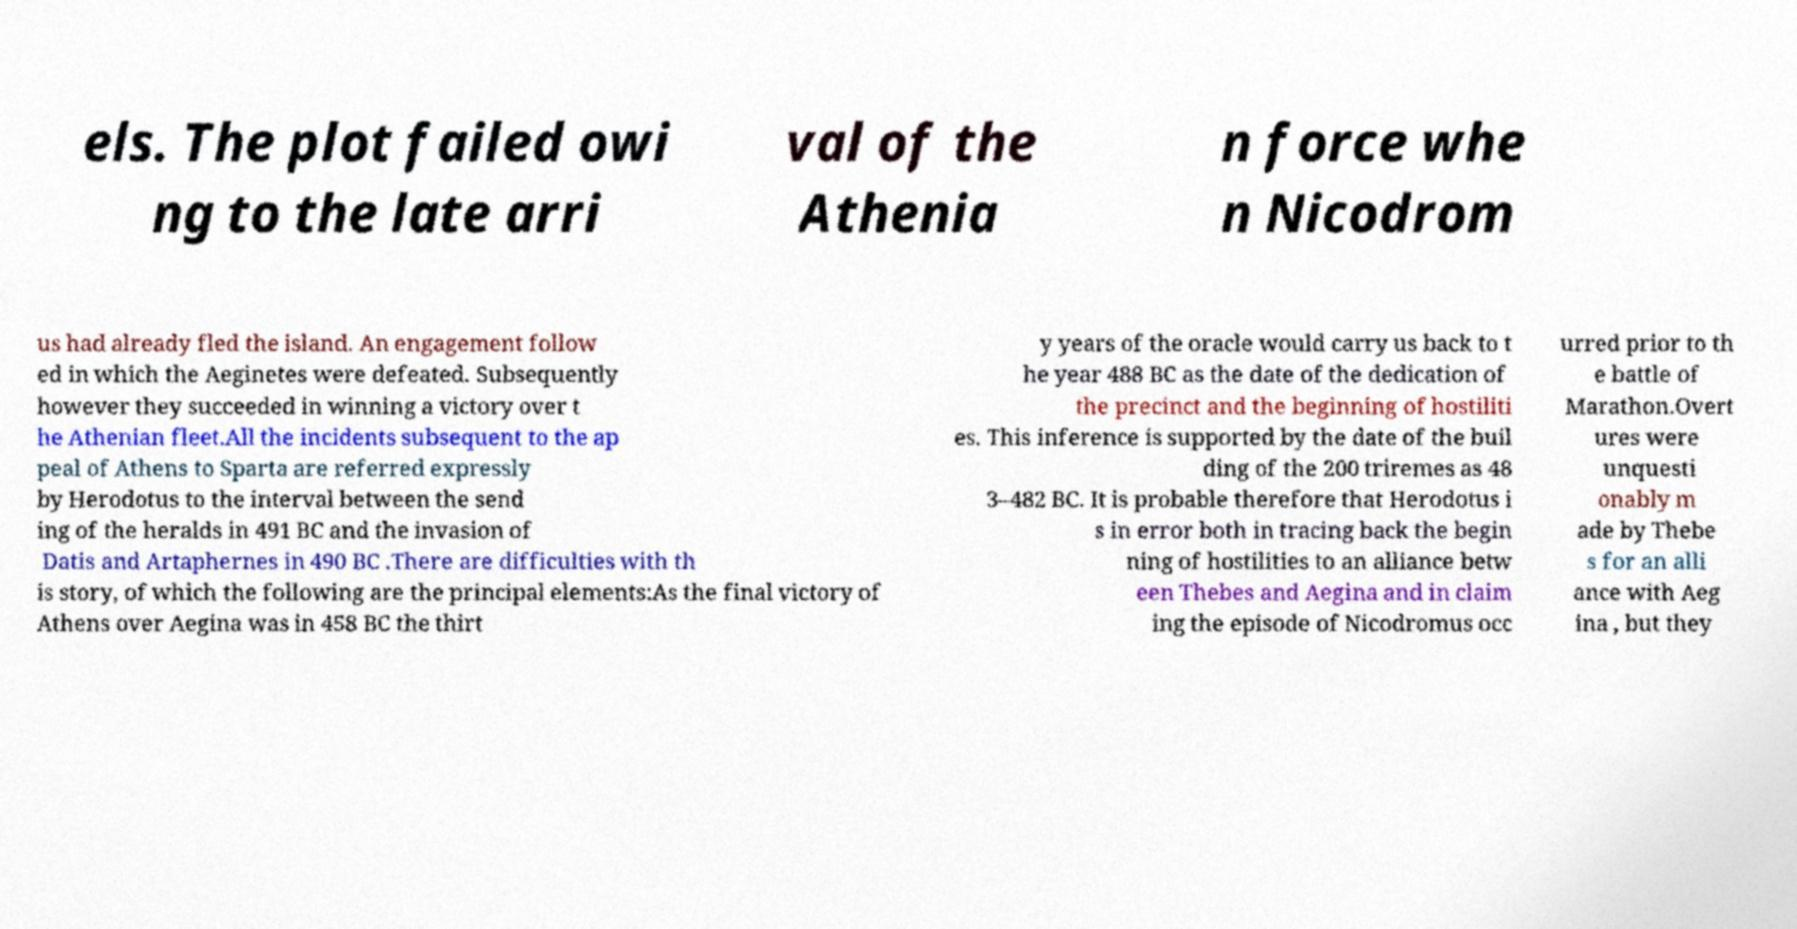Could you assist in decoding the text presented in this image and type it out clearly? els. The plot failed owi ng to the late arri val of the Athenia n force whe n Nicodrom us had already fled the island. An engagement follow ed in which the Aeginetes were defeated. Subsequently however they succeeded in winning a victory over t he Athenian fleet.All the incidents subsequent to the ap peal of Athens to Sparta are referred expressly by Herodotus to the interval between the send ing of the heralds in 491 BC and the invasion of Datis and Artaphernes in 490 BC .There are difficulties with th is story, of which the following are the principal elements:As the final victory of Athens over Aegina was in 458 BC the thirt y years of the oracle would carry us back to t he year 488 BC as the date of the dedication of the precinct and the beginning of hostiliti es. This inference is supported by the date of the buil ding of the 200 triremes as 48 3–482 BC. It is probable therefore that Herodotus i s in error both in tracing back the begin ning of hostilities to an alliance betw een Thebes and Aegina and in claim ing the episode of Nicodromus occ urred prior to th e battle of Marathon.Overt ures were unquesti onably m ade by Thebe s for an alli ance with Aeg ina , but they 